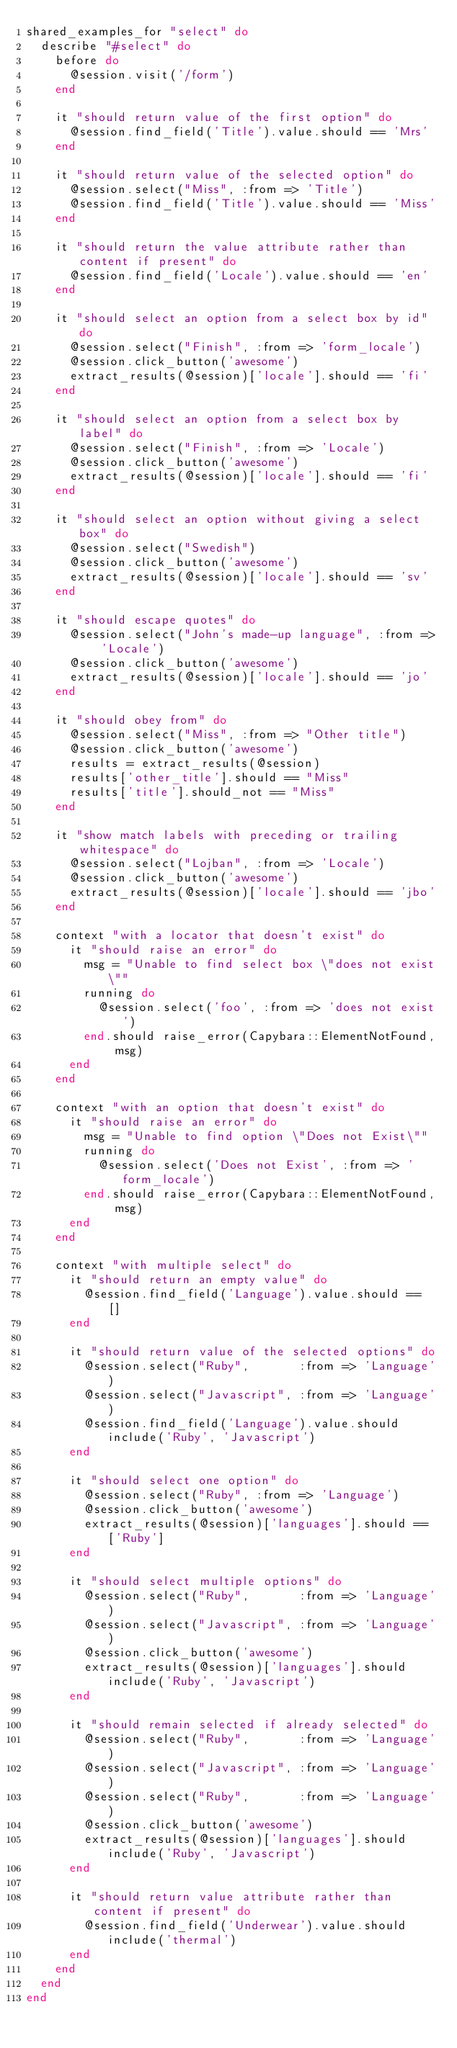<code> <loc_0><loc_0><loc_500><loc_500><_Ruby_>shared_examples_for "select" do
  describe "#select" do
    before do
      @session.visit('/form')
    end

    it "should return value of the first option" do
      @session.find_field('Title').value.should == 'Mrs'
    end

    it "should return value of the selected option" do
      @session.select("Miss", :from => 'Title')
      @session.find_field('Title').value.should == 'Miss'
    end

    it "should return the value attribute rather than content if present" do
      @session.find_field('Locale').value.should == 'en'
    end

    it "should select an option from a select box by id" do
      @session.select("Finish", :from => 'form_locale')
      @session.click_button('awesome')
      extract_results(@session)['locale'].should == 'fi'
    end

    it "should select an option from a select box by label" do
      @session.select("Finish", :from => 'Locale')
      @session.click_button('awesome')
      extract_results(@session)['locale'].should == 'fi'
    end

    it "should select an option without giving a select box" do
      @session.select("Swedish")
      @session.click_button('awesome')
      extract_results(@session)['locale'].should == 'sv'
    end

    it "should escape quotes" do
      @session.select("John's made-up language", :from => 'Locale')
      @session.click_button('awesome')
      extract_results(@session)['locale'].should == 'jo'
    end

    it "should obey from" do
      @session.select("Miss", :from => "Other title")
      @session.click_button('awesome')
      results = extract_results(@session)
      results['other_title'].should == "Miss"
      results['title'].should_not == "Miss"
    end

    it "show match labels with preceding or trailing whitespace" do
      @session.select("Lojban", :from => 'Locale')
      @session.click_button('awesome')
      extract_results(@session)['locale'].should == 'jbo'
    end

    context "with a locator that doesn't exist" do
      it "should raise an error" do
        msg = "Unable to find select box \"does not exist\""
        running do
          @session.select('foo', :from => 'does not exist')
        end.should raise_error(Capybara::ElementNotFound, msg)
      end
    end

    context "with an option that doesn't exist" do
      it "should raise an error" do
        msg = "Unable to find option \"Does not Exist\""
        running do
          @session.select('Does not Exist', :from => 'form_locale')
        end.should raise_error(Capybara::ElementNotFound, msg)
      end
    end

    context "with multiple select" do
      it "should return an empty value" do
        @session.find_field('Language').value.should == []
      end

      it "should return value of the selected options" do
        @session.select("Ruby",       :from => 'Language')
        @session.select("Javascript", :from => 'Language')
        @session.find_field('Language').value.should include('Ruby', 'Javascript')
      end

      it "should select one option" do
        @session.select("Ruby", :from => 'Language')
        @session.click_button('awesome')
        extract_results(@session)['languages'].should == ['Ruby']
      end

      it "should select multiple options" do
        @session.select("Ruby",       :from => 'Language')
        @session.select("Javascript", :from => 'Language')
        @session.click_button('awesome')
        extract_results(@session)['languages'].should include('Ruby', 'Javascript')
      end

      it "should remain selected if already selected" do
        @session.select("Ruby",       :from => 'Language')
        @session.select("Javascript", :from => 'Language')
        @session.select("Ruby",       :from => 'Language')
        @session.click_button('awesome')
        extract_results(@session)['languages'].should include('Ruby', 'Javascript')
      end

      it "should return value attribute rather than content if present" do
        @session.find_field('Underwear').value.should include('thermal')
      end
    end
  end
end
</code> 